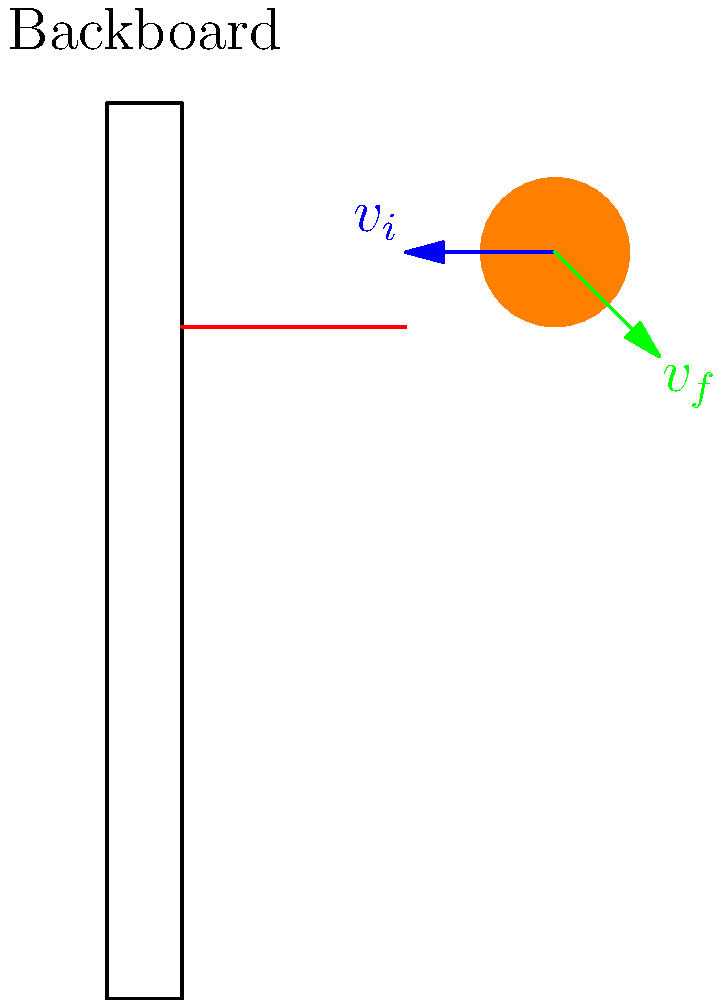During a crucial game against the Manhattan Jaspers in the 1994-95 season, you attempt a bank shot. The basketball, with a mass of 0.62 kg, approaches the backboard at 7.5 m/s and rebounds at 5.3 m/s at a 45° angle to the backboard. What percentage of the ball's initial kinetic energy is lost in this collision? To solve this problem, we'll follow these steps:

1) Calculate the initial kinetic energy of the ball:
   $KE_i = \frac{1}{2}mv_i^2$
   $KE_i = \frac{1}{2}(0.62)(7.5^2) = 17.44$ J

2) Calculate the final kinetic energy of the ball:
   $KE_f = \frac{1}{2}mv_f^2$
   $KE_f = \frac{1}{2}(0.62)(5.3^2) = 8.70$ J

3) Calculate the energy lost:
   $E_{lost} = KE_i - KE_f = 17.44 - 8.70 = 8.74$ J

4) Calculate the percentage of energy lost:
   $\text{Percentage lost} = \frac{E_{lost}}{KE_i} \times 100\%$
   $\text{Percentage lost} = \frac{8.74}{17.44} \times 100\% = 50.11\%$

Therefore, approximately 50.11% of the ball's initial kinetic energy is lost in the collision with the backboard.
Answer: 50.11% 